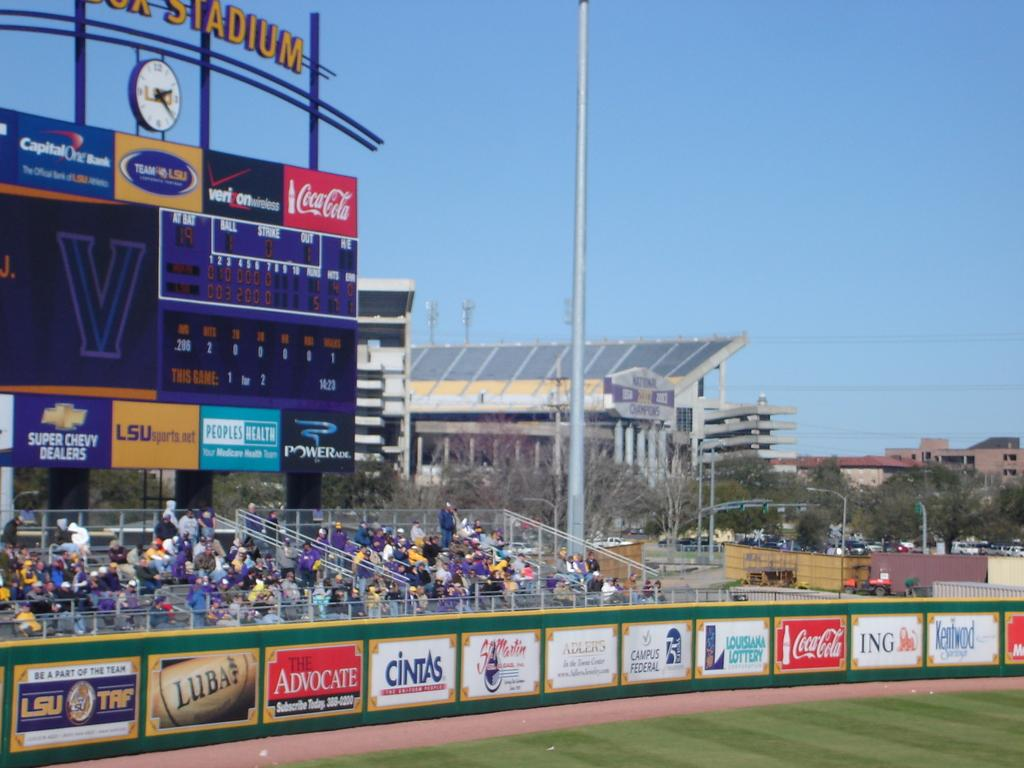<image>
Provide a brief description of the given image. A baseball field with advertisements like The Advocate and Campus Federal 